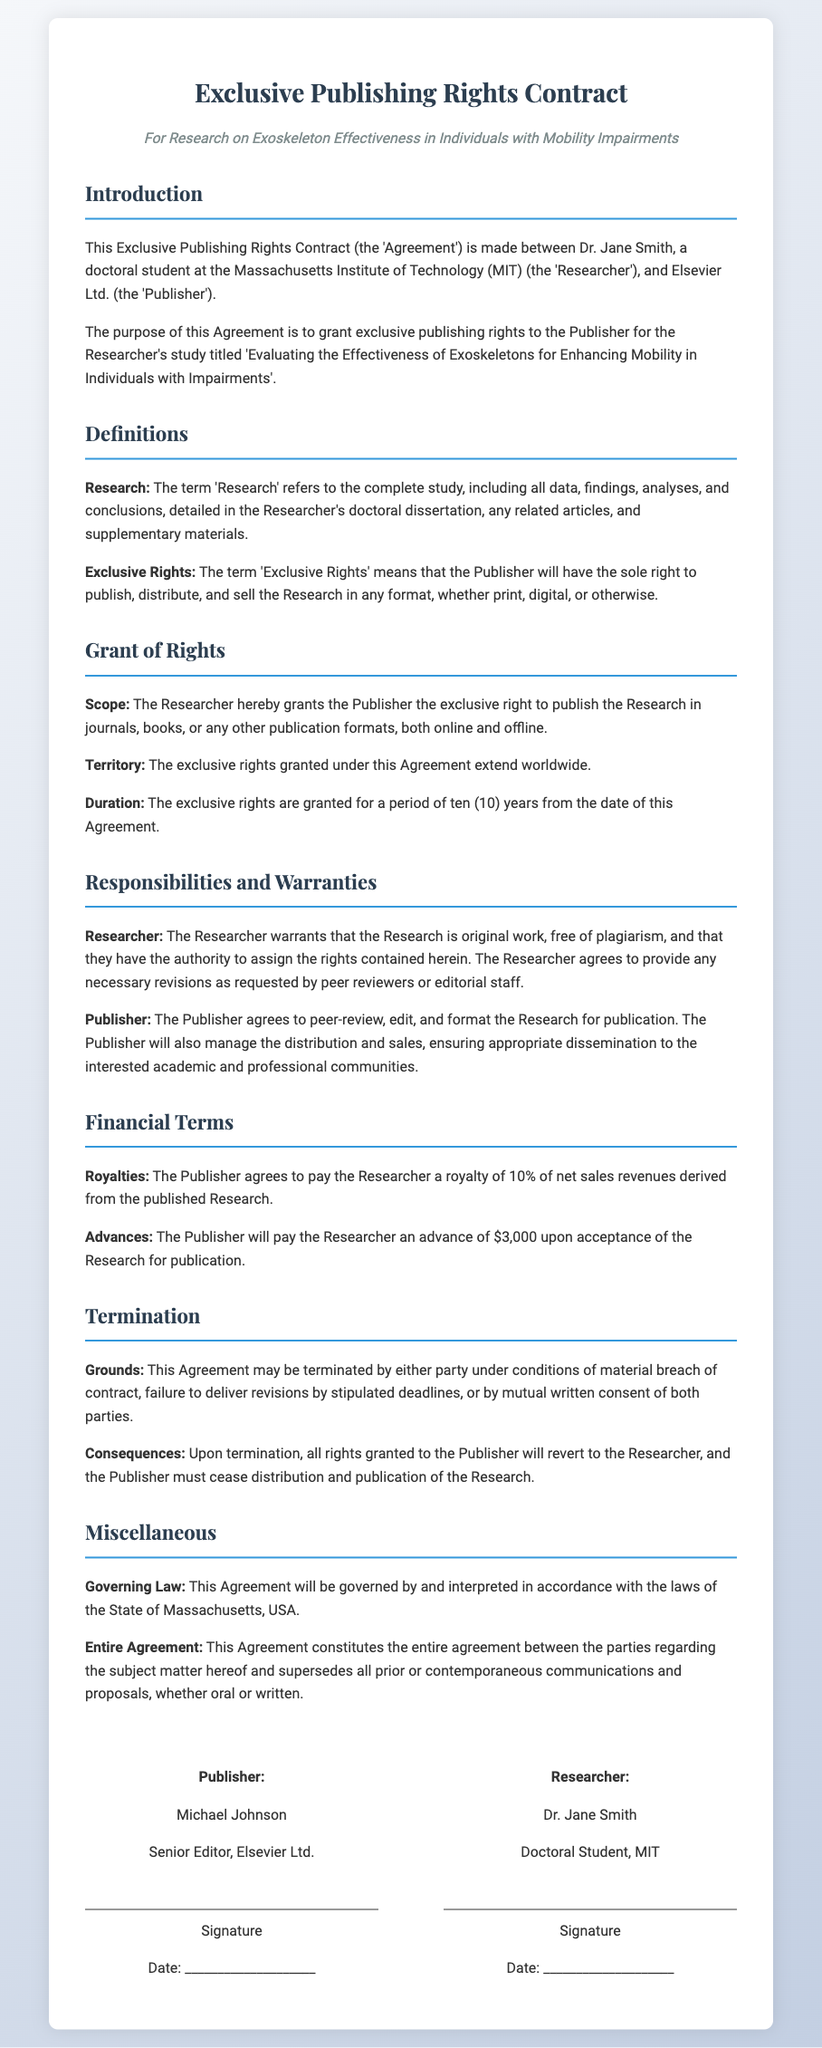What is the name of the researcher? The name of the researcher is specified in the introduction of the document.
Answer: Dr. Jane Smith Who is the publisher? The publisher's name is mentioned in the introduction of the contract.
Answer: Elsevier Ltd What is the duration of the exclusive rights? The duration of the exclusive rights is detailed in the grant of rights section.
Answer: Ten (10) years What is the advance payment amount? The advance payment amount is listed in the financial terms section of the document.
Answer: $3,000 What percentage of royalties will the researcher receive? The percentage of royalties for the researcher is specified in the financial terms section.
Answer: 10% Under what conditions can the agreement be terminated? The conditions for termination are outlined in the termination section of the agreement.
Answer: Material breach What law governs this agreement? The governing law for the agreement is mentioned in the miscellaneous section.
Answer: State of Massachusetts What is the title of the research study? The title of the research study is presented in the introduction of the document.
Answer: Evaluating the Effectiveness of Exoskeletons for Enhancing Mobility in Individuals with Impairments Who must agree to revisions requested by peer reviewers? The responsibilities regarding revisions are detailed in the responsibilities section of the document.
Answer: The Researcher 